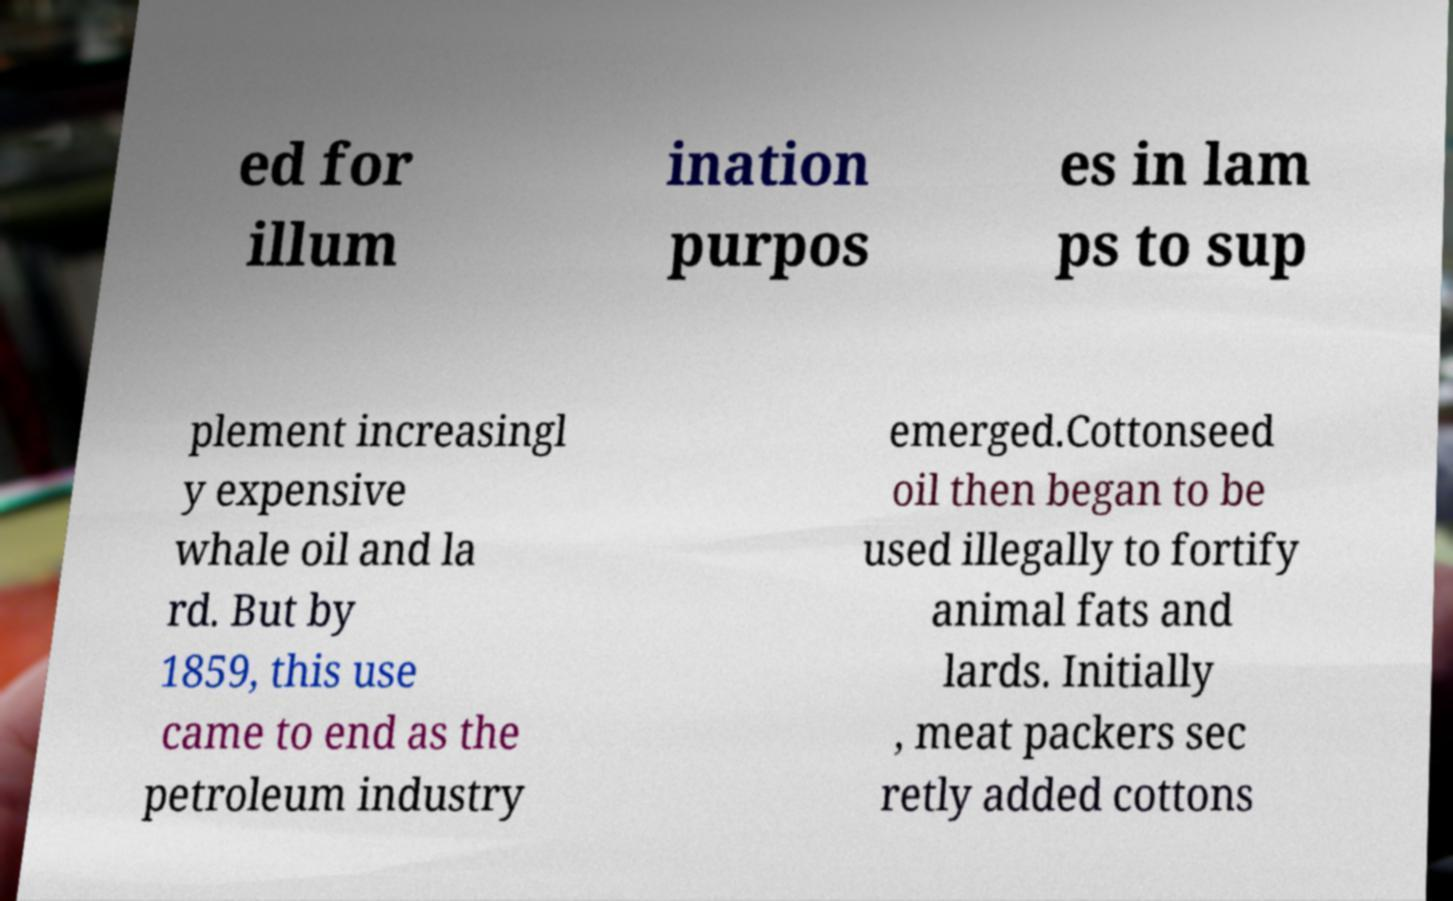I need the written content from this picture converted into text. Can you do that? ed for illum ination purpos es in lam ps to sup plement increasingl y expensive whale oil and la rd. But by 1859, this use came to end as the petroleum industry emerged.Cottonseed oil then began to be used illegally to fortify animal fats and lards. Initially , meat packers sec retly added cottons 